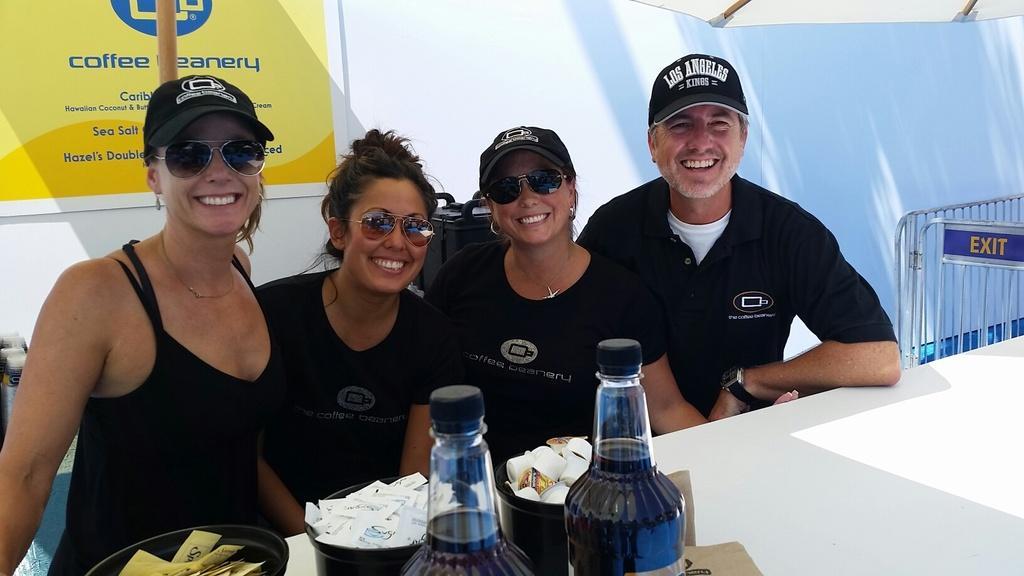How would you summarize this image in a sentence or two? These four persons are sitting. This three persons wearing cap. We can see table. On the table we can see bottle,bowl,paper. On the background we can see banner. 